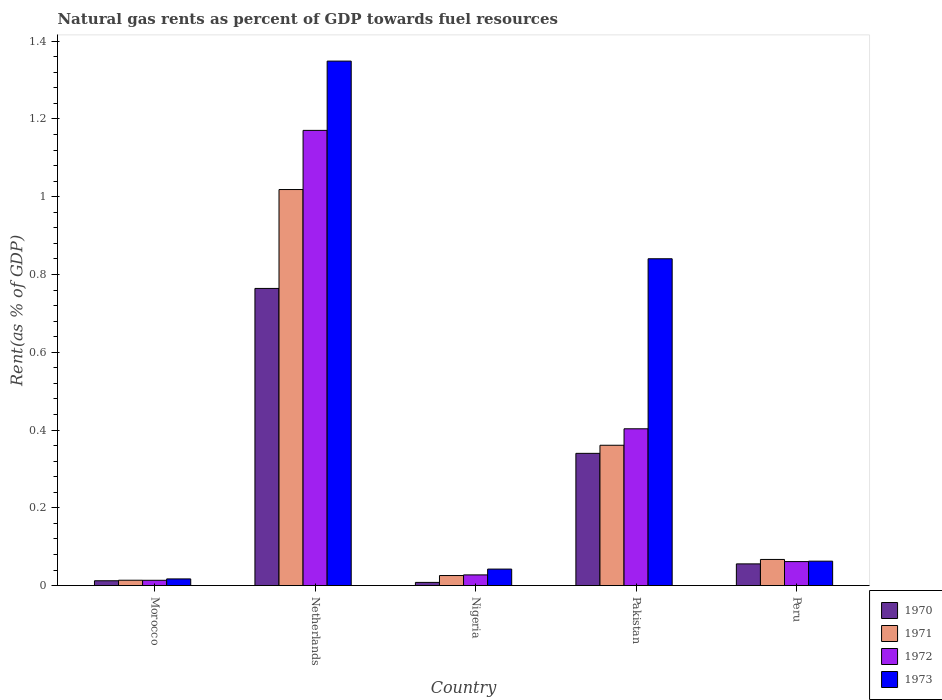How many different coloured bars are there?
Offer a terse response. 4. How many groups of bars are there?
Provide a succinct answer. 5. Are the number of bars per tick equal to the number of legend labels?
Your answer should be compact. Yes. How many bars are there on the 4th tick from the left?
Your answer should be compact. 4. How many bars are there on the 5th tick from the right?
Offer a terse response. 4. What is the label of the 5th group of bars from the left?
Your response must be concise. Peru. What is the matural gas rent in 1973 in Nigeria?
Keep it short and to the point. 0.04. Across all countries, what is the maximum matural gas rent in 1972?
Offer a terse response. 1.17. Across all countries, what is the minimum matural gas rent in 1971?
Keep it short and to the point. 0.01. In which country was the matural gas rent in 1971 minimum?
Your answer should be compact. Morocco. What is the total matural gas rent in 1972 in the graph?
Provide a succinct answer. 1.68. What is the difference between the matural gas rent in 1973 in Netherlands and that in Pakistan?
Provide a short and direct response. 0.51. What is the difference between the matural gas rent in 1972 in Nigeria and the matural gas rent in 1973 in Pakistan?
Make the answer very short. -0.81. What is the average matural gas rent in 1970 per country?
Provide a succinct answer. 0.24. What is the difference between the matural gas rent of/in 1971 and matural gas rent of/in 1972 in Nigeria?
Your answer should be compact. -0. In how many countries, is the matural gas rent in 1972 greater than 1.12 %?
Offer a very short reply. 1. What is the ratio of the matural gas rent in 1971 in Morocco to that in Netherlands?
Ensure brevity in your answer.  0.01. Is the matural gas rent in 1971 in Pakistan less than that in Peru?
Provide a short and direct response. No. Is the difference between the matural gas rent in 1971 in Morocco and Pakistan greater than the difference between the matural gas rent in 1972 in Morocco and Pakistan?
Ensure brevity in your answer.  Yes. What is the difference between the highest and the second highest matural gas rent in 1972?
Offer a very short reply. -0.77. What is the difference between the highest and the lowest matural gas rent in 1970?
Ensure brevity in your answer.  0.76. In how many countries, is the matural gas rent in 1973 greater than the average matural gas rent in 1973 taken over all countries?
Provide a succinct answer. 2. Is the sum of the matural gas rent in 1972 in Pakistan and Peru greater than the maximum matural gas rent in 1970 across all countries?
Give a very brief answer. No. What does the 1st bar from the left in Netherlands represents?
Your answer should be very brief. 1970. What does the 2nd bar from the right in Nigeria represents?
Your answer should be very brief. 1972. Is it the case that in every country, the sum of the matural gas rent in 1970 and matural gas rent in 1971 is greater than the matural gas rent in 1973?
Provide a succinct answer. No. How many bars are there?
Offer a very short reply. 20. What is the difference between two consecutive major ticks on the Y-axis?
Offer a terse response. 0.2. Does the graph contain grids?
Offer a terse response. No. How many legend labels are there?
Your answer should be compact. 4. How are the legend labels stacked?
Offer a very short reply. Vertical. What is the title of the graph?
Keep it short and to the point. Natural gas rents as percent of GDP towards fuel resources. Does "1991" appear as one of the legend labels in the graph?
Provide a short and direct response. No. What is the label or title of the X-axis?
Make the answer very short. Country. What is the label or title of the Y-axis?
Your answer should be compact. Rent(as % of GDP). What is the Rent(as % of GDP) of 1970 in Morocco?
Offer a very short reply. 0.01. What is the Rent(as % of GDP) in 1971 in Morocco?
Your response must be concise. 0.01. What is the Rent(as % of GDP) in 1972 in Morocco?
Give a very brief answer. 0.01. What is the Rent(as % of GDP) in 1973 in Morocco?
Your response must be concise. 0.02. What is the Rent(as % of GDP) in 1970 in Netherlands?
Give a very brief answer. 0.76. What is the Rent(as % of GDP) in 1971 in Netherlands?
Offer a very short reply. 1.02. What is the Rent(as % of GDP) in 1972 in Netherlands?
Provide a succinct answer. 1.17. What is the Rent(as % of GDP) of 1973 in Netherlands?
Your response must be concise. 1.35. What is the Rent(as % of GDP) of 1970 in Nigeria?
Your response must be concise. 0.01. What is the Rent(as % of GDP) of 1971 in Nigeria?
Make the answer very short. 0.03. What is the Rent(as % of GDP) in 1972 in Nigeria?
Provide a succinct answer. 0.03. What is the Rent(as % of GDP) of 1973 in Nigeria?
Offer a terse response. 0.04. What is the Rent(as % of GDP) in 1970 in Pakistan?
Offer a very short reply. 0.34. What is the Rent(as % of GDP) in 1971 in Pakistan?
Provide a succinct answer. 0.36. What is the Rent(as % of GDP) in 1972 in Pakistan?
Your answer should be very brief. 0.4. What is the Rent(as % of GDP) of 1973 in Pakistan?
Your answer should be compact. 0.84. What is the Rent(as % of GDP) of 1970 in Peru?
Provide a short and direct response. 0.06. What is the Rent(as % of GDP) of 1971 in Peru?
Your response must be concise. 0.07. What is the Rent(as % of GDP) in 1972 in Peru?
Offer a very short reply. 0.06. What is the Rent(as % of GDP) in 1973 in Peru?
Provide a succinct answer. 0.06. Across all countries, what is the maximum Rent(as % of GDP) in 1970?
Ensure brevity in your answer.  0.76. Across all countries, what is the maximum Rent(as % of GDP) of 1971?
Give a very brief answer. 1.02. Across all countries, what is the maximum Rent(as % of GDP) of 1972?
Provide a short and direct response. 1.17. Across all countries, what is the maximum Rent(as % of GDP) in 1973?
Keep it short and to the point. 1.35. Across all countries, what is the minimum Rent(as % of GDP) of 1970?
Provide a short and direct response. 0.01. Across all countries, what is the minimum Rent(as % of GDP) of 1971?
Offer a terse response. 0.01. Across all countries, what is the minimum Rent(as % of GDP) in 1972?
Your answer should be very brief. 0.01. Across all countries, what is the minimum Rent(as % of GDP) of 1973?
Offer a terse response. 0.02. What is the total Rent(as % of GDP) in 1970 in the graph?
Ensure brevity in your answer.  1.18. What is the total Rent(as % of GDP) of 1971 in the graph?
Provide a short and direct response. 1.49. What is the total Rent(as % of GDP) in 1972 in the graph?
Your answer should be compact. 1.68. What is the total Rent(as % of GDP) in 1973 in the graph?
Your answer should be compact. 2.31. What is the difference between the Rent(as % of GDP) of 1970 in Morocco and that in Netherlands?
Keep it short and to the point. -0.75. What is the difference between the Rent(as % of GDP) in 1971 in Morocco and that in Netherlands?
Ensure brevity in your answer.  -1. What is the difference between the Rent(as % of GDP) in 1972 in Morocco and that in Netherlands?
Offer a very short reply. -1.16. What is the difference between the Rent(as % of GDP) in 1973 in Morocco and that in Netherlands?
Make the answer very short. -1.33. What is the difference between the Rent(as % of GDP) in 1970 in Morocco and that in Nigeria?
Offer a very short reply. 0. What is the difference between the Rent(as % of GDP) in 1971 in Morocco and that in Nigeria?
Your answer should be very brief. -0.01. What is the difference between the Rent(as % of GDP) of 1972 in Morocco and that in Nigeria?
Provide a short and direct response. -0.01. What is the difference between the Rent(as % of GDP) in 1973 in Morocco and that in Nigeria?
Your answer should be very brief. -0.03. What is the difference between the Rent(as % of GDP) of 1970 in Morocco and that in Pakistan?
Keep it short and to the point. -0.33. What is the difference between the Rent(as % of GDP) in 1971 in Morocco and that in Pakistan?
Your answer should be compact. -0.35. What is the difference between the Rent(as % of GDP) in 1972 in Morocco and that in Pakistan?
Provide a short and direct response. -0.39. What is the difference between the Rent(as % of GDP) of 1973 in Morocco and that in Pakistan?
Keep it short and to the point. -0.82. What is the difference between the Rent(as % of GDP) of 1970 in Morocco and that in Peru?
Offer a terse response. -0.04. What is the difference between the Rent(as % of GDP) of 1971 in Morocco and that in Peru?
Ensure brevity in your answer.  -0.05. What is the difference between the Rent(as % of GDP) of 1972 in Morocco and that in Peru?
Give a very brief answer. -0.05. What is the difference between the Rent(as % of GDP) of 1973 in Morocco and that in Peru?
Your answer should be very brief. -0.05. What is the difference between the Rent(as % of GDP) in 1970 in Netherlands and that in Nigeria?
Make the answer very short. 0.76. What is the difference between the Rent(as % of GDP) of 1972 in Netherlands and that in Nigeria?
Offer a very short reply. 1.14. What is the difference between the Rent(as % of GDP) of 1973 in Netherlands and that in Nigeria?
Give a very brief answer. 1.31. What is the difference between the Rent(as % of GDP) in 1970 in Netherlands and that in Pakistan?
Ensure brevity in your answer.  0.42. What is the difference between the Rent(as % of GDP) of 1971 in Netherlands and that in Pakistan?
Provide a short and direct response. 0.66. What is the difference between the Rent(as % of GDP) of 1972 in Netherlands and that in Pakistan?
Make the answer very short. 0.77. What is the difference between the Rent(as % of GDP) in 1973 in Netherlands and that in Pakistan?
Your response must be concise. 0.51. What is the difference between the Rent(as % of GDP) of 1970 in Netherlands and that in Peru?
Your answer should be very brief. 0.71. What is the difference between the Rent(as % of GDP) of 1971 in Netherlands and that in Peru?
Provide a short and direct response. 0.95. What is the difference between the Rent(as % of GDP) in 1972 in Netherlands and that in Peru?
Provide a short and direct response. 1.11. What is the difference between the Rent(as % of GDP) in 1973 in Netherlands and that in Peru?
Your answer should be very brief. 1.29. What is the difference between the Rent(as % of GDP) of 1970 in Nigeria and that in Pakistan?
Your answer should be compact. -0.33. What is the difference between the Rent(as % of GDP) of 1971 in Nigeria and that in Pakistan?
Your answer should be very brief. -0.34. What is the difference between the Rent(as % of GDP) of 1972 in Nigeria and that in Pakistan?
Offer a terse response. -0.38. What is the difference between the Rent(as % of GDP) of 1973 in Nigeria and that in Pakistan?
Provide a succinct answer. -0.8. What is the difference between the Rent(as % of GDP) of 1970 in Nigeria and that in Peru?
Provide a succinct answer. -0.05. What is the difference between the Rent(as % of GDP) in 1971 in Nigeria and that in Peru?
Give a very brief answer. -0.04. What is the difference between the Rent(as % of GDP) of 1972 in Nigeria and that in Peru?
Your answer should be very brief. -0.03. What is the difference between the Rent(as % of GDP) in 1973 in Nigeria and that in Peru?
Provide a short and direct response. -0.02. What is the difference between the Rent(as % of GDP) of 1970 in Pakistan and that in Peru?
Your answer should be compact. 0.28. What is the difference between the Rent(as % of GDP) of 1971 in Pakistan and that in Peru?
Your response must be concise. 0.29. What is the difference between the Rent(as % of GDP) of 1972 in Pakistan and that in Peru?
Give a very brief answer. 0.34. What is the difference between the Rent(as % of GDP) in 1973 in Pakistan and that in Peru?
Offer a terse response. 0.78. What is the difference between the Rent(as % of GDP) of 1970 in Morocco and the Rent(as % of GDP) of 1971 in Netherlands?
Your answer should be very brief. -1.01. What is the difference between the Rent(as % of GDP) of 1970 in Morocco and the Rent(as % of GDP) of 1972 in Netherlands?
Your response must be concise. -1.16. What is the difference between the Rent(as % of GDP) of 1970 in Morocco and the Rent(as % of GDP) of 1973 in Netherlands?
Offer a very short reply. -1.34. What is the difference between the Rent(as % of GDP) in 1971 in Morocco and the Rent(as % of GDP) in 1972 in Netherlands?
Offer a very short reply. -1.16. What is the difference between the Rent(as % of GDP) in 1971 in Morocco and the Rent(as % of GDP) in 1973 in Netherlands?
Provide a succinct answer. -1.33. What is the difference between the Rent(as % of GDP) of 1972 in Morocco and the Rent(as % of GDP) of 1973 in Netherlands?
Your answer should be compact. -1.34. What is the difference between the Rent(as % of GDP) in 1970 in Morocco and the Rent(as % of GDP) in 1971 in Nigeria?
Your response must be concise. -0.01. What is the difference between the Rent(as % of GDP) of 1970 in Morocco and the Rent(as % of GDP) of 1972 in Nigeria?
Offer a terse response. -0.02. What is the difference between the Rent(as % of GDP) in 1970 in Morocco and the Rent(as % of GDP) in 1973 in Nigeria?
Ensure brevity in your answer.  -0.03. What is the difference between the Rent(as % of GDP) in 1971 in Morocco and the Rent(as % of GDP) in 1972 in Nigeria?
Your response must be concise. -0.01. What is the difference between the Rent(as % of GDP) of 1971 in Morocco and the Rent(as % of GDP) of 1973 in Nigeria?
Offer a very short reply. -0.03. What is the difference between the Rent(as % of GDP) of 1972 in Morocco and the Rent(as % of GDP) of 1973 in Nigeria?
Make the answer very short. -0.03. What is the difference between the Rent(as % of GDP) of 1970 in Morocco and the Rent(as % of GDP) of 1971 in Pakistan?
Your answer should be compact. -0.35. What is the difference between the Rent(as % of GDP) in 1970 in Morocco and the Rent(as % of GDP) in 1972 in Pakistan?
Offer a terse response. -0.39. What is the difference between the Rent(as % of GDP) of 1970 in Morocco and the Rent(as % of GDP) of 1973 in Pakistan?
Your response must be concise. -0.83. What is the difference between the Rent(as % of GDP) in 1971 in Morocco and the Rent(as % of GDP) in 1972 in Pakistan?
Keep it short and to the point. -0.39. What is the difference between the Rent(as % of GDP) of 1971 in Morocco and the Rent(as % of GDP) of 1973 in Pakistan?
Your answer should be very brief. -0.83. What is the difference between the Rent(as % of GDP) in 1972 in Morocco and the Rent(as % of GDP) in 1973 in Pakistan?
Your answer should be very brief. -0.83. What is the difference between the Rent(as % of GDP) in 1970 in Morocco and the Rent(as % of GDP) in 1971 in Peru?
Offer a terse response. -0.05. What is the difference between the Rent(as % of GDP) in 1970 in Morocco and the Rent(as % of GDP) in 1972 in Peru?
Your response must be concise. -0.05. What is the difference between the Rent(as % of GDP) of 1970 in Morocco and the Rent(as % of GDP) of 1973 in Peru?
Make the answer very short. -0.05. What is the difference between the Rent(as % of GDP) in 1971 in Morocco and the Rent(as % of GDP) in 1972 in Peru?
Your answer should be very brief. -0.05. What is the difference between the Rent(as % of GDP) of 1971 in Morocco and the Rent(as % of GDP) of 1973 in Peru?
Offer a very short reply. -0.05. What is the difference between the Rent(as % of GDP) of 1972 in Morocco and the Rent(as % of GDP) of 1973 in Peru?
Offer a very short reply. -0.05. What is the difference between the Rent(as % of GDP) in 1970 in Netherlands and the Rent(as % of GDP) in 1971 in Nigeria?
Your response must be concise. 0.74. What is the difference between the Rent(as % of GDP) of 1970 in Netherlands and the Rent(as % of GDP) of 1972 in Nigeria?
Give a very brief answer. 0.74. What is the difference between the Rent(as % of GDP) in 1970 in Netherlands and the Rent(as % of GDP) in 1973 in Nigeria?
Keep it short and to the point. 0.72. What is the difference between the Rent(as % of GDP) in 1972 in Netherlands and the Rent(as % of GDP) in 1973 in Nigeria?
Keep it short and to the point. 1.13. What is the difference between the Rent(as % of GDP) of 1970 in Netherlands and the Rent(as % of GDP) of 1971 in Pakistan?
Provide a succinct answer. 0.4. What is the difference between the Rent(as % of GDP) of 1970 in Netherlands and the Rent(as % of GDP) of 1972 in Pakistan?
Make the answer very short. 0.36. What is the difference between the Rent(as % of GDP) in 1970 in Netherlands and the Rent(as % of GDP) in 1973 in Pakistan?
Your answer should be very brief. -0.08. What is the difference between the Rent(as % of GDP) in 1971 in Netherlands and the Rent(as % of GDP) in 1972 in Pakistan?
Offer a terse response. 0.62. What is the difference between the Rent(as % of GDP) of 1971 in Netherlands and the Rent(as % of GDP) of 1973 in Pakistan?
Your response must be concise. 0.18. What is the difference between the Rent(as % of GDP) of 1972 in Netherlands and the Rent(as % of GDP) of 1973 in Pakistan?
Provide a short and direct response. 0.33. What is the difference between the Rent(as % of GDP) in 1970 in Netherlands and the Rent(as % of GDP) in 1971 in Peru?
Give a very brief answer. 0.7. What is the difference between the Rent(as % of GDP) in 1970 in Netherlands and the Rent(as % of GDP) in 1972 in Peru?
Make the answer very short. 0.7. What is the difference between the Rent(as % of GDP) in 1970 in Netherlands and the Rent(as % of GDP) in 1973 in Peru?
Make the answer very short. 0.7. What is the difference between the Rent(as % of GDP) of 1971 in Netherlands and the Rent(as % of GDP) of 1972 in Peru?
Give a very brief answer. 0.96. What is the difference between the Rent(as % of GDP) in 1971 in Netherlands and the Rent(as % of GDP) in 1973 in Peru?
Give a very brief answer. 0.96. What is the difference between the Rent(as % of GDP) in 1972 in Netherlands and the Rent(as % of GDP) in 1973 in Peru?
Offer a very short reply. 1.11. What is the difference between the Rent(as % of GDP) in 1970 in Nigeria and the Rent(as % of GDP) in 1971 in Pakistan?
Your response must be concise. -0.35. What is the difference between the Rent(as % of GDP) of 1970 in Nigeria and the Rent(as % of GDP) of 1972 in Pakistan?
Your answer should be compact. -0.4. What is the difference between the Rent(as % of GDP) in 1970 in Nigeria and the Rent(as % of GDP) in 1973 in Pakistan?
Offer a terse response. -0.83. What is the difference between the Rent(as % of GDP) of 1971 in Nigeria and the Rent(as % of GDP) of 1972 in Pakistan?
Provide a succinct answer. -0.38. What is the difference between the Rent(as % of GDP) in 1971 in Nigeria and the Rent(as % of GDP) in 1973 in Pakistan?
Offer a terse response. -0.81. What is the difference between the Rent(as % of GDP) of 1972 in Nigeria and the Rent(as % of GDP) of 1973 in Pakistan?
Offer a terse response. -0.81. What is the difference between the Rent(as % of GDP) in 1970 in Nigeria and the Rent(as % of GDP) in 1971 in Peru?
Offer a very short reply. -0.06. What is the difference between the Rent(as % of GDP) of 1970 in Nigeria and the Rent(as % of GDP) of 1972 in Peru?
Provide a short and direct response. -0.05. What is the difference between the Rent(as % of GDP) in 1970 in Nigeria and the Rent(as % of GDP) in 1973 in Peru?
Your answer should be compact. -0.05. What is the difference between the Rent(as % of GDP) of 1971 in Nigeria and the Rent(as % of GDP) of 1972 in Peru?
Give a very brief answer. -0.04. What is the difference between the Rent(as % of GDP) of 1971 in Nigeria and the Rent(as % of GDP) of 1973 in Peru?
Provide a short and direct response. -0.04. What is the difference between the Rent(as % of GDP) of 1972 in Nigeria and the Rent(as % of GDP) of 1973 in Peru?
Your response must be concise. -0.04. What is the difference between the Rent(as % of GDP) of 1970 in Pakistan and the Rent(as % of GDP) of 1971 in Peru?
Make the answer very short. 0.27. What is the difference between the Rent(as % of GDP) in 1970 in Pakistan and the Rent(as % of GDP) in 1972 in Peru?
Give a very brief answer. 0.28. What is the difference between the Rent(as % of GDP) of 1970 in Pakistan and the Rent(as % of GDP) of 1973 in Peru?
Your response must be concise. 0.28. What is the difference between the Rent(as % of GDP) of 1971 in Pakistan and the Rent(as % of GDP) of 1972 in Peru?
Your response must be concise. 0.3. What is the difference between the Rent(as % of GDP) of 1971 in Pakistan and the Rent(as % of GDP) of 1973 in Peru?
Offer a terse response. 0.3. What is the difference between the Rent(as % of GDP) in 1972 in Pakistan and the Rent(as % of GDP) in 1973 in Peru?
Your response must be concise. 0.34. What is the average Rent(as % of GDP) in 1970 per country?
Keep it short and to the point. 0.24. What is the average Rent(as % of GDP) of 1971 per country?
Provide a succinct answer. 0.3. What is the average Rent(as % of GDP) in 1972 per country?
Give a very brief answer. 0.34. What is the average Rent(as % of GDP) of 1973 per country?
Your answer should be very brief. 0.46. What is the difference between the Rent(as % of GDP) in 1970 and Rent(as % of GDP) in 1971 in Morocco?
Make the answer very short. -0. What is the difference between the Rent(as % of GDP) in 1970 and Rent(as % of GDP) in 1972 in Morocco?
Ensure brevity in your answer.  -0. What is the difference between the Rent(as % of GDP) of 1970 and Rent(as % of GDP) of 1973 in Morocco?
Your answer should be very brief. -0. What is the difference between the Rent(as % of GDP) in 1971 and Rent(as % of GDP) in 1972 in Morocco?
Keep it short and to the point. 0. What is the difference between the Rent(as % of GDP) in 1971 and Rent(as % of GDP) in 1973 in Morocco?
Your answer should be very brief. -0. What is the difference between the Rent(as % of GDP) in 1972 and Rent(as % of GDP) in 1973 in Morocco?
Your answer should be compact. -0. What is the difference between the Rent(as % of GDP) in 1970 and Rent(as % of GDP) in 1971 in Netherlands?
Provide a succinct answer. -0.25. What is the difference between the Rent(as % of GDP) of 1970 and Rent(as % of GDP) of 1972 in Netherlands?
Provide a short and direct response. -0.41. What is the difference between the Rent(as % of GDP) in 1970 and Rent(as % of GDP) in 1973 in Netherlands?
Your response must be concise. -0.58. What is the difference between the Rent(as % of GDP) in 1971 and Rent(as % of GDP) in 1972 in Netherlands?
Your response must be concise. -0.15. What is the difference between the Rent(as % of GDP) in 1971 and Rent(as % of GDP) in 1973 in Netherlands?
Your answer should be very brief. -0.33. What is the difference between the Rent(as % of GDP) of 1972 and Rent(as % of GDP) of 1973 in Netherlands?
Provide a succinct answer. -0.18. What is the difference between the Rent(as % of GDP) in 1970 and Rent(as % of GDP) in 1971 in Nigeria?
Provide a succinct answer. -0.02. What is the difference between the Rent(as % of GDP) of 1970 and Rent(as % of GDP) of 1972 in Nigeria?
Offer a very short reply. -0.02. What is the difference between the Rent(as % of GDP) in 1970 and Rent(as % of GDP) in 1973 in Nigeria?
Make the answer very short. -0.03. What is the difference between the Rent(as % of GDP) of 1971 and Rent(as % of GDP) of 1972 in Nigeria?
Provide a succinct answer. -0. What is the difference between the Rent(as % of GDP) of 1971 and Rent(as % of GDP) of 1973 in Nigeria?
Your response must be concise. -0.02. What is the difference between the Rent(as % of GDP) in 1972 and Rent(as % of GDP) in 1973 in Nigeria?
Offer a terse response. -0.01. What is the difference between the Rent(as % of GDP) of 1970 and Rent(as % of GDP) of 1971 in Pakistan?
Ensure brevity in your answer.  -0.02. What is the difference between the Rent(as % of GDP) in 1970 and Rent(as % of GDP) in 1972 in Pakistan?
Give a very brief answer. -0.06. What is the difference between the Rent(as % of GDP) of 1970 and Rent(as % of GDP) of 1973 in Pakistan?
Your answer should be very brief. -0.5. What is the difference between the Rent(as % of GDP) of 1971 and Rent(as % of GDP) of 1972 in Pakistan?
Your answer should be compact. -0.04. What is the difference between the Rent(as % of GDP) of 1971 and Rent(as % of GDP) of 1973 in Pakistan?
Make the answer very short. -0.48. What is the difference between the Rent(as % of GDP) in 1972 and Rent(as % of GDP) in 1973 in Pakistan?
Your answer should be compact. -0.44. What is the difference between the Rent(as % of GDP) of 1970 and Rent(as % of GDP) of 1971 in Peru?
Offer a very short reply. -0.01. What is the difference between the Rent(as % of GDP) in 1970 and Rent(as % of GDP) in 1972 in Peru?
Provide a succinct answer. -0.01. What is the difference between the Rent(as % of GDP) of 1970 and Rent(as % of GDP) of 1973 in Peru?
Make the answer very short. -0.01. What is the difference between the Rent(as % of GDP) in 1971 and Rent(as % of GDP) in 1972 in Peru?
Your answer should be very brief. 0.01. What is the difference between the Rent(as % of GDP) of 1971 and Rent(as % of GDP) of 1973 in Peru?
Give a very brief answer. 0. What is the difference between the Rent(as % of GDP) in 1972 and Rent(as % of GDP) in 1973 in Peru?
Provide a succinct answer. -0. What is the ratio of the Rent(as % of GDP) in 1970 in Morocco to that in Netherlands?
Give a very brief answer. 0.02. What is the ratio of the Rent(as % of GDP) in 1971 in Morocco to that in Netherlands?
Your response must be concise. 0.01. What is the ratio of the Rent(as % of GDP) in 1972 in Morocco to that in Netherlands?
Offer a very short reply. 0.01. What is the ratio of the Rent(as % of GDP) of 1973 in Morocco to that in Netherlands?
Your response must be concise. 0.01. What is the ratio of the Rent(as % of GDP) in 1970 in Morocco to that in Nigeria?
Provide a succinct answer. 1.52. What is the ratio of the Rent(as % of GDP) of 1971 in Morocco to that in Nigeria?
Make the answer very short. 0.53. What is the ratio of the Rent(as % of GDP) of 1972 in Morocco to that in Nigeria?
Provide a succinct answer. 0.49. What is the ratio of the Rent(as % of GDP) in 1973 in Morocco to that in Nigeria?
Ensure brevity in your answer.  0.4. What is the ratio of the Rent(as % of GDP) of 1970 in Morocco to that in Pakistan?
Provide a succinct answer. 0.04. What is the ratio of the Rent(as % of GDP) in 1971 in Morocco to that in Pakistan?
Offer a very short reply. 0.04. What is the ratio of the Rent(as % of GDP) of 1972 in Morocco to that in Pakistan?
Your answer should be very brief. 0.03. What is the ratio of the Rent(as % of GDP) of 1973 in Morocco to that in Pakistan?
Provide a short and direct response. 0.02. What is the ratio of the Rent(as % of GDP) of 1970 in Morocco to that in Peru?
Your response must be concise. 0.22. What is the ratio of the Rent(as % of GDP) in 1971 in Morocco to that in Peru?
Offer a very short reply. 0.2. What is the ratio of the Rent(as % of GDP) of 1972 in Morocco to that in Peru?
Ensure brevity in your answer.  0.22. What is the ratio of the Rent(as % of GDP) of 1973 in Morocco to that in Peru?
Provide a succinct answer. 0.27. What is the ratio of the Rent(as % of GDP) in 1970 in Netherlands to that in Nigeria?
Your response must be concise. 93.94. What is the ratio of the Rent(as % of GDP) in 1971 in Netherlands to that in Nigeria?
Offer a terse response. 39.48. What is the ratio of the Rent(as % of GDP) in 1972 in Netherlands to that in Nigeria?
Your answer should be compact. 42.7. What is the ratio of the Rent(as % of GDP) in 1973 in Netherlands to that in Nigeria?
Offer a very short reply. 31.84. What is the ratio of the Rent(as % of GDP) of 1970 in Netherlands to that in Pakistan?
Keep it short and to the point. 2.25. What is the ratio of the Rent(as % of GDP) of 1971 in Netherlands to that in Pakistan?
Keep it short and to the point. 2.82. What is the ratio of the Rent(as % of GDP) of 1972 in Netherlands to that in Pakistan?
Give a very brief answer. 2.9. What is the ratio of the Rent(as % of GDP) in 1973 in Netherlands to that in Pakistan?
Offer a very short reply. 1.6. What is the ratio of the Rent(as % of GDP) in 1970 in Netherlands to that in Peru?
Keep it short and to the point. 13.7. What is the ratio of the Rent(as % of GDP) in 1971 in Netherlands to that in Peru?
Provide a short and direct response. 15.16. What is the ratio of the Rent(as % of GDP) of 1972 in Netherlands to that in Peru?
Your answer should be compact. 18.98. What is the ratio of the Rent(as % of GDP) of 1973 in Netherlands to that in Peru?
Ensure brevity in your answer.  21.49. What is the ratio of the Rent(as % of GDP) in 1970 in Nigeria to that in Pakistan?
Give a very brief answer. 0.02. What is the ratio of the Rent(as % of GDP) in 1971 in Nigeria to that in Pakistan?
Your answer should be very brief. 0.07. What is the ratio of the Rent(as % of GDP) of 1972 in Nigeria to that in Pakistan?
Your answer should be very brief. 0.07. What is the ratio of the Rent(as % of GDP) in 1973 in Nigeria to that in Pakistan?
Ensure brevity in your answer.  0.05. What is the ratio of the Rent(as % of GDP) in 1970 in Nigeria to that in Peru?
Provide a short and direct response. 0.15. What is the ratio of the Rent(as % of GDP) in 1971 in Nigeria to that in Peru?
Offer a very short reply. 0.38. What is the ratio of the Rent(as % of GDP) of 1972 in Nigeria to that in Peru?
Make the answer very short. 0.44. What is the ratio of the Rent(as % of GDP) in 1973 in Nigeria to that in Peru?
Make the answer very short. 0.67. What is the ratio of the Rent(as % of GDP) in 1970 in Pakistan to that in Peru?
Give a very brief answer. 6.1. What is the ratio of the Rent(as % of GDP) of 1971 in Pakistan to that in Peru?
Provide a succinct answer. 5.37. What is the ratio of the Rent(as % of GDP) in 1972 in Pakistan to that in Peru?
Your response must be concise. 6.54. What is the ratio of the Rent(as % of GDP) in 1973 in Pakistan to that in Peru?
Your answer should be very brief. 13.39. What is the difference between the highest and the second highest Rent(as % of GDP) of 1970?
Offer a terse response. 0.42. What is the difference between the highest and the second highest Rent(as % of GDP) of 1971?
Provide a succinct answer. 0.66. What is the difference between the highest and the second highest Rent(as % of GDP) in 1972?
Give a very brief answer. 0.77. What is the difference between the highest and the second highest Rent(as % of GDP) of 1973?
Your response must be concise. 0.51. What is the difference between the highest and the lowest Rent(as % of GDP) of 1970?
Ensure brevity in your answer.  0.76. What is the difference between the highest and the lowest Rent(as % of GDP) of 1971?
Your response must be concise. 1. What is the difference between the highest and the lowest Rent(as % of GDP) of 1972?
Ensure brevity in your answer.  1.16. What is the difference between the highest and the lowest Rent(as % of GDP) in 1973?
Give a very brief answer. 1.33. 